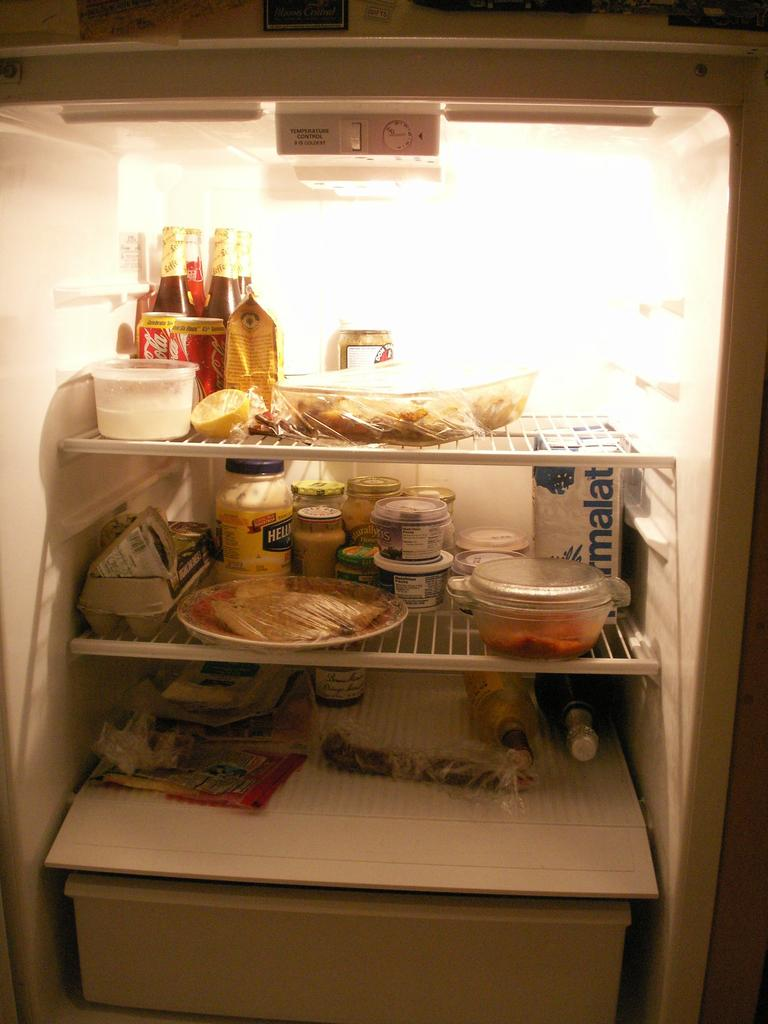<image>
Create a compact narrative representing the image presented. An open refrigerator with various foods and drinks including cans of coca-cola 